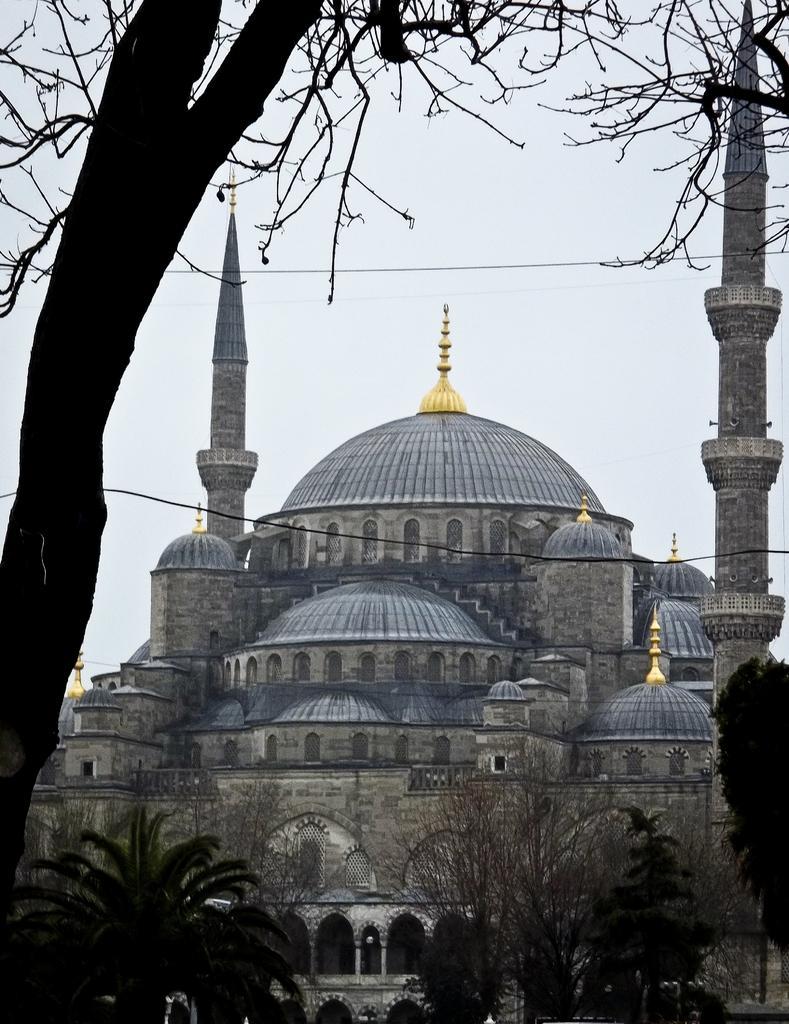How would you summarize this image in a sentence or two? In the image I can see some buildings and around there are some trees and plants. 